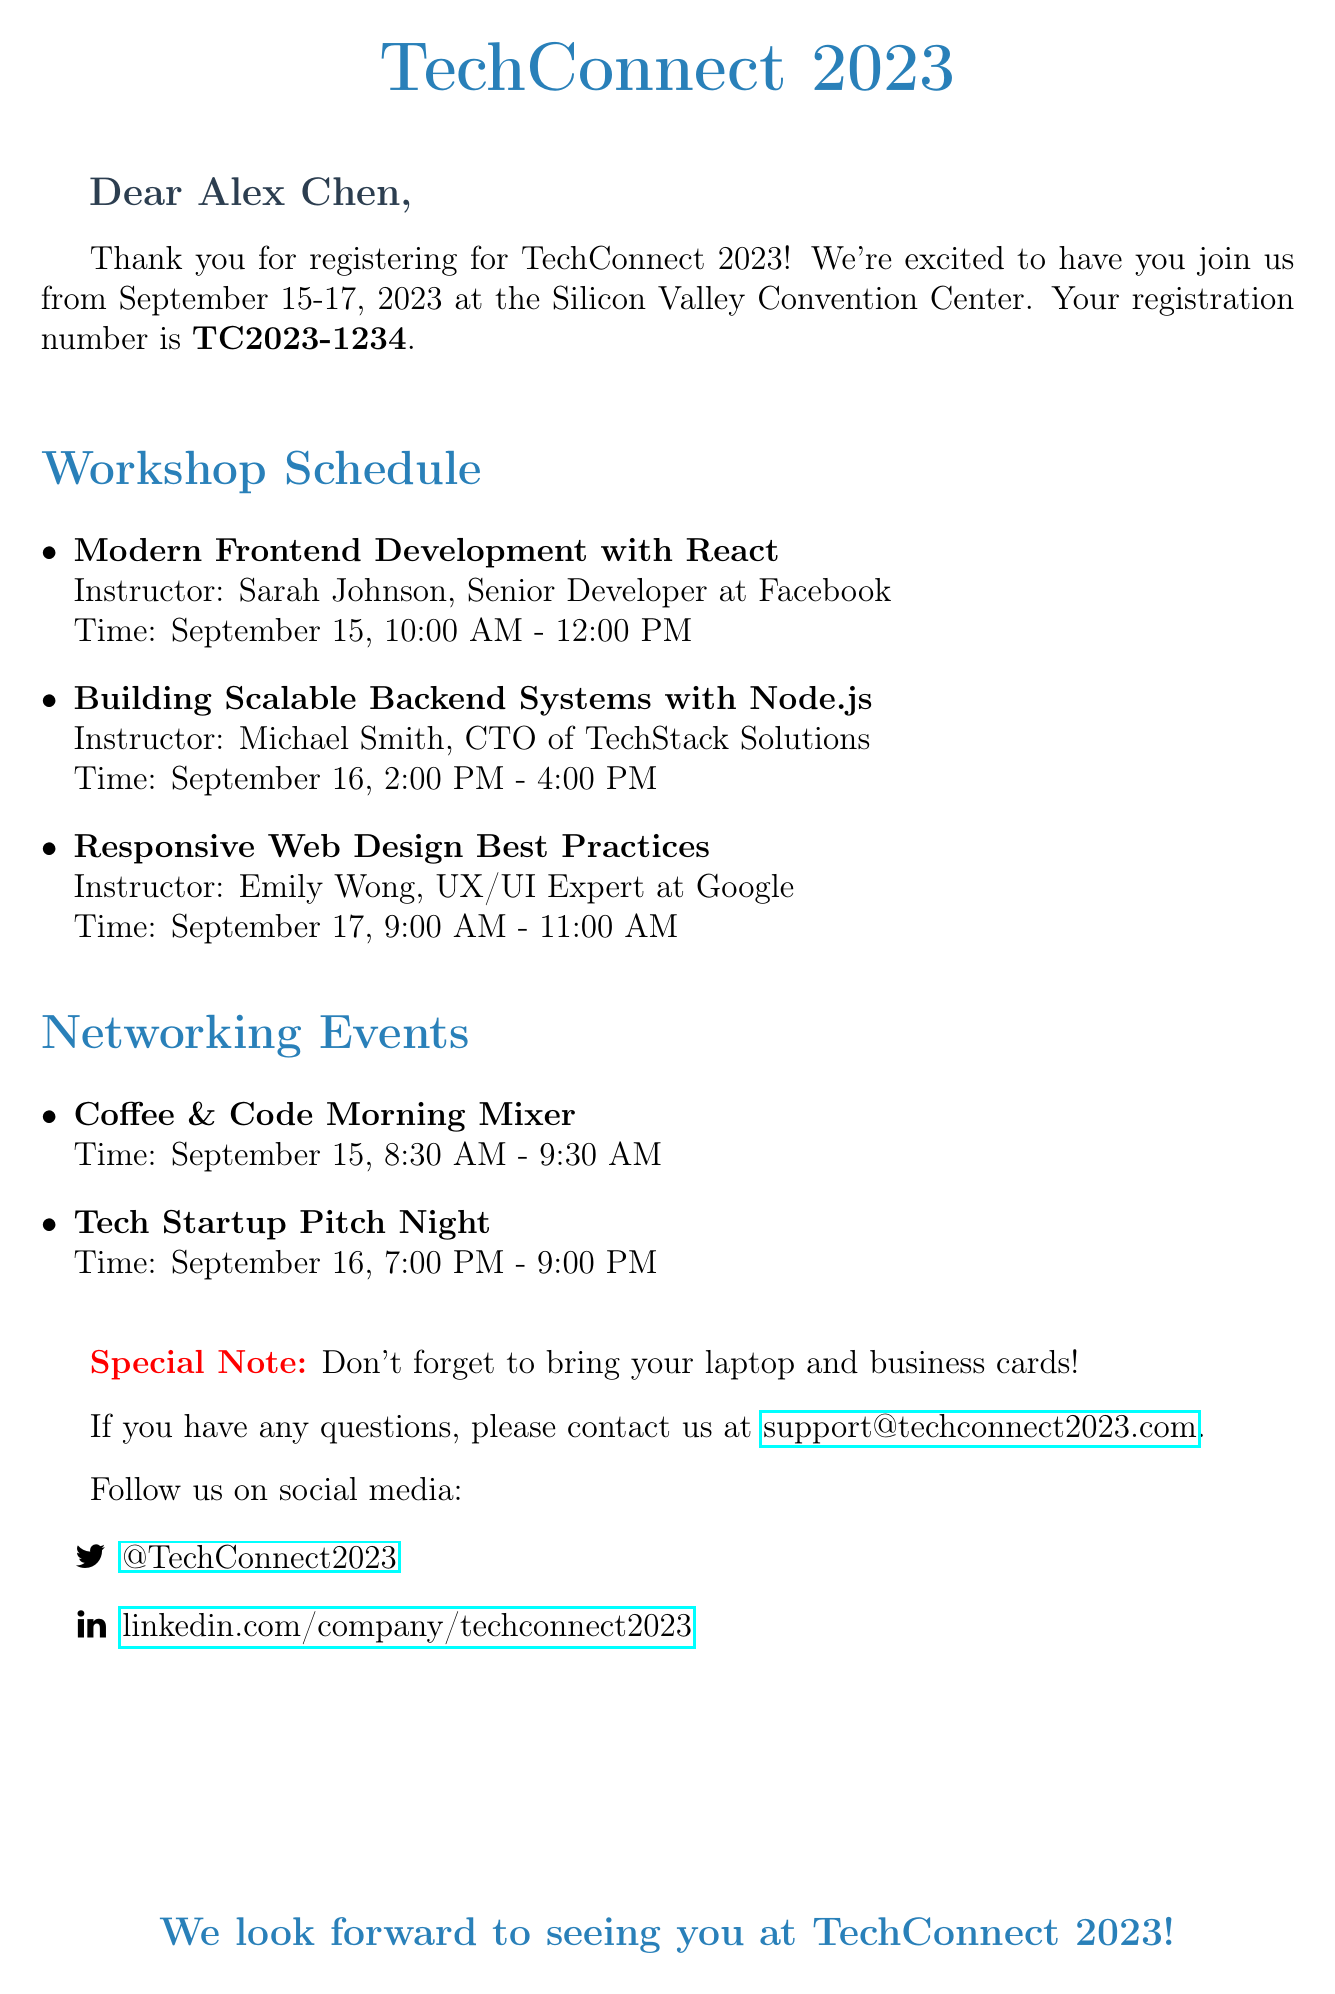What are the dates of the conference? The conference will take place from September 15 to September 17, 2023.
Answer: September 15-17, 2023 What is the venue for TechConnect 2023? The venue for the conference is the Silicon Valley Convention Center.
Answer: Silicon Valley Convention Center Who is instructing the workshop on Frontend Development? The instructor for the Modern Frontend Development with React workshop is Sarah Johnson.
Answer: Sarah Johnson What time does the Coffee & Code Morning Mixer start? The Coffee & Code Morning Mixer is scheduled to start at 8:30 AM on September 15.
Answer: 8:30 AM How many workshops are listed in the document? There are three workshops mentioned in the document.
Answer: Three What is the registration number given in the email? The registration number for the conference is TC2023-1234.
Answer: TC2023-1234 What special note is included in the email? The special note reminds attendees to bring their laptop and business cards.
Answer: Bring your laptop and business cards How many networking events are mentioned? There are two networking events listed in the document.
Answer: Two What is the contact email for support? The email provided for support inquiries is support@techconnect2023.com.
Answer: support@techconnect2023.com 